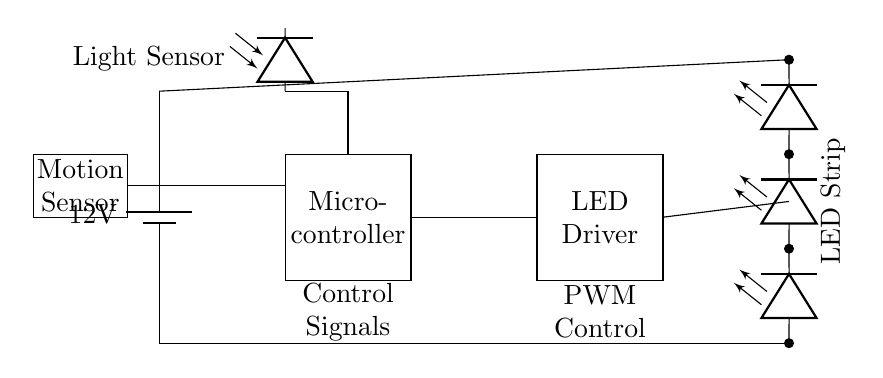What is the power supply voltage? The voltage supplied to the circuit is 12 volts, indicated by the battery symbol in the diagram.
Answer: 12 volts What component receives control signals? The microcontroller is the component that receives the control signals, as shown by the label adjacent to it in the circuit diagram.
Answer: Microcontroller What type of sensor is connected to the microcontroller? A motion sensor is connected to the microcontroller, as represented by the labeled rectangle indicating its functionality.
Answer: Motion sensor What does PWM stand for in this circuit? PWM stands for Pulse Width Modulation, which is shown in the diagram next to the LED driver that utilizes this control method for regulating brightness.
Answer: Pulse Width Modulation How many LED strips are present in the circuit? There are four LED strips depicted in the circuit, shown as multiple LED symbols connected in series outlined in the schematic diagram.
Answer: Four What role does the light sensor play in this circuit? The light sensor detects ambient light levels, and this information is used by the microcontroller to adjust the brightness of the LEDs accordingly.
Answer: Adjust brightness What is the purpose of the LED driver in this circuit? The LED driver is responsible for providing the correct current to the LED strips, ensuring they operate efficiently and effectively without damage.
Answer: Provide current 